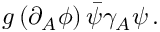Convert formula to latex. <formula><loc_0><loc_0><loc_500><loc_500>g \, ( \partial _ { A } \phi ) \, \bar { \psi } \gamma _ { A } \psi \, .</formula> 